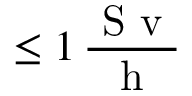<formula> <loc_0><loc_0><loc_500><loc_500>\leq 1 \, \frac { S v } { h }</formula> 